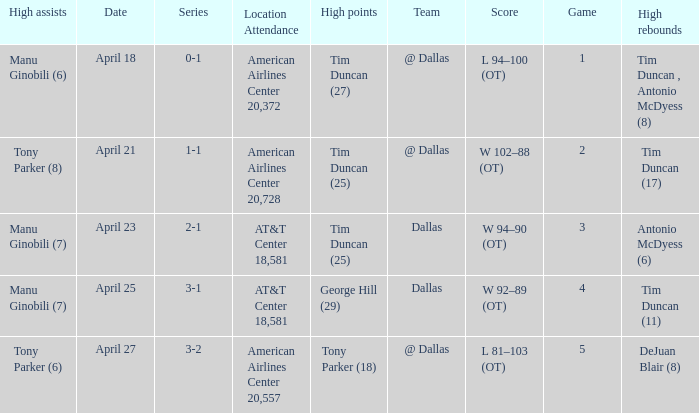When george hill (29) has the highest amount of points what is the date? April 25. 